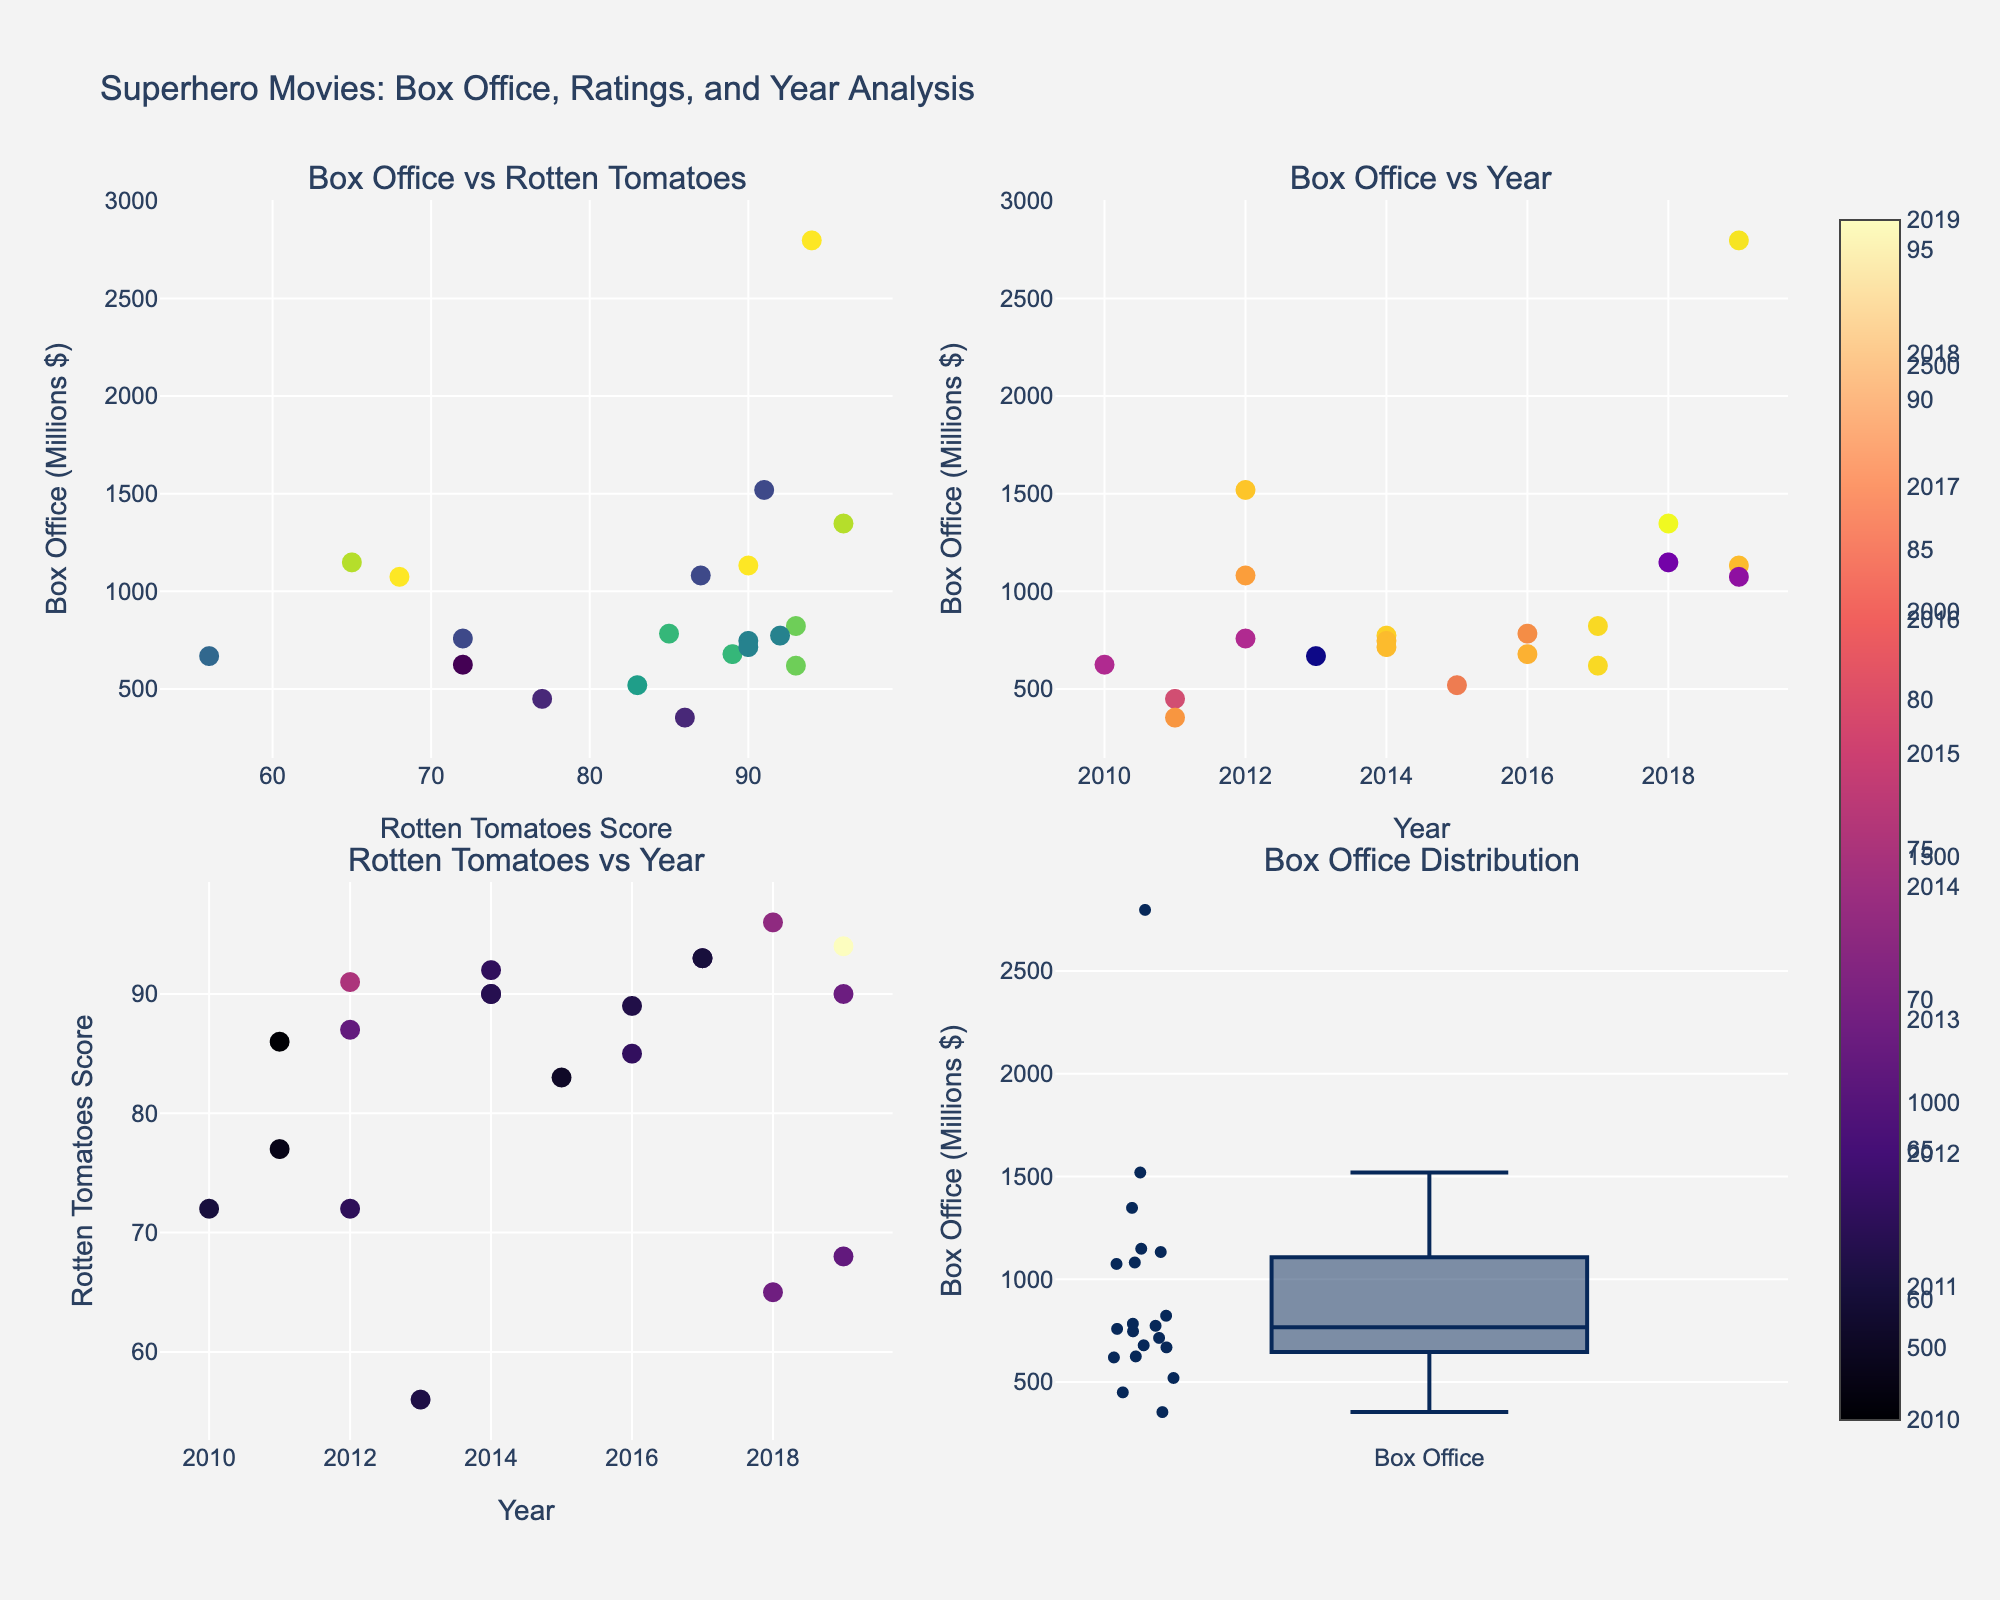What's the title of the figure? The title is located at the top of the figure. It reads 'Superhero Movies: Box Office, Ratings, and Year Analysis', representing the overall content and purpose of the figure.
Answer: Superhero Movies: Box Office, Ratings, and Year Analysis What is the highest Rotten Tomatoes score recorded in the scatter plot of the "Box Office vs Rotten Tomatoes"? By examining the "Box Office vs Rotten Tomatoes" subplot in the top left, we can see that the highest Rotten Tomatoes score is 96.
Answer: 96 Which movie had the highest box office earnings? Looking at the scatter plot with Rotten Tomatoes scores and box office earnings in the top left subplot, the movie with the highest box office earnings is positioned highest on the y-axis. "Avengers: Endgame" tops the chart with a box office earning of 2,797 million dollars.
Answer: Avengers: Endgame Among the movies released in 2018, which one had the highest Rotten Tomatoes score? In the "Rotten Tomatoes vs Year" scatter plot at the bottom left, we locate the data points for the year 2018. Among these, "Black Panther" stands out with the highest Rotten Tomatoes score of 96.
Answer: Black Panther How does the box office earnings distribution appear in the subplot at the bottom right? The box plot in the bottom right subplot shows the distribution of box office earnings. The spread of the data points, including potential outliers, is represented. The main concentration is around the lower box office values with a few movies achieving significantly higher earnings.
Answer: Skewed with some high outliers What are the colors representing in the "Box Office vs Year" scatter plot? Each marker's color in the top right scatter plot correlates with the Rotten Tomatoes scores. The color scale ranges from lower scores (darker colors) to higher scores (brighter colors).
Answer: Rotten Tomatoes scores Which movie released in 2014 had the highest Rotten Tomatoes score? In the "Rotten Tomatoes vs Year" scatter plot at the bottom left, the data points for the year 2014 show that "Guardians of the Galaxy" had the highest score with 92.
Answer: Guardians of the Galaxy Comparing "Avengers: Endgame" and "Joker", which had higher Rotten Tomatoes scores, and by how much? From the "Box Office vs Rotten Tomatoes" subplot, "Avengers: Endgame" has a score of 94 and "Joker" has a score of 68. The difference is calculated as 94 - 68 = 26.
Answer: Avengers: Endgame, by 26 Which movie released in 2012 had the highest box office earnings? In the "Box Office vs Year" scatter plot, we identify the data points for the year 2012. "The Avengers" had the highest box office earnings with 1,519 million dollars.
Answer: The Avengers What can you infer about the relationship between Rotten Tomatoes scores and box office earnings based on the scatter plot? By analyzing the correlation in the "Box Office vs Rotten Tomatoes" subplot, positive trends are moderately noticeable but not very strong. High box office earnings sometimes correlate with high Rotten Tomatoes scores, but several outliers exist.
Answer: Moderate positive trend, but with outliers 